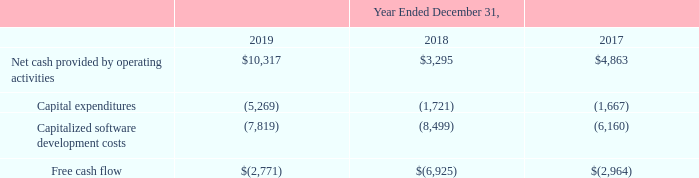Free Cash Flow. Free cash flow represents net cash provided by operating activities minus capital expenditures and capitalized software development costs. Free cash flow is a measure used by management to understand and evaluate our core operating performance and trends and to generate future operating plans.
The exclusion of capital expenditures and amounts capitalized for internally-developed software facilitates comparisons of our operating performance on a period-to-period basis and excludes items that we do not consider to be indicative of our core operating performance. Free cash flow is not a measure calculated in accordance with GAAP. We believe that free cash flow provides useful information to investors and others in understanding and evaluating our operating results in the same manner as our management and board of directors.
Nevertheless, our use of free cash flow has limitations as an analytical tool, and you should not consider it in isolation or as a substitute for analysis of our financial results as reported under GAAP. You should consider free cash flow alongside our other GAAP-based financial performance measures, net cash provided by operating activities, and our other GAAP financial results. The following table presents a reconciliation of free cash flow to net cash for operating activities, the most directly comparable GAAP measure, for each of the periods indicated (in thousands):
What does Free Cash Flow represent? Net cash provided by operating activities minus capital expenditures and capitalized software development costs. What is Free Cash Flow used as? By management to understand and evaluate our core operating performance and trends and to generate future operating plans. What was the Net cash provided by operating activities in 2019, 2018 and 2017 respectively? 10,317, 3,295, 4,863. What was the average Net cash provided by operating activities from 2017-2019?
Answer scale should be: thousand. (10,317 + 3,295 + 4,863) / 3
Answer: 6158.33. What was the change in the Capital expenditures from 2018 to 2019?
Answer scale should be: thousand. -5,269 - (- 1,721)
Answer: -3548. In which year was Net cash provided by operating activities less than 5,000 thousands? Locate and analyze net cash provided by operating activities in row 3
answer: 2018, 2017. 